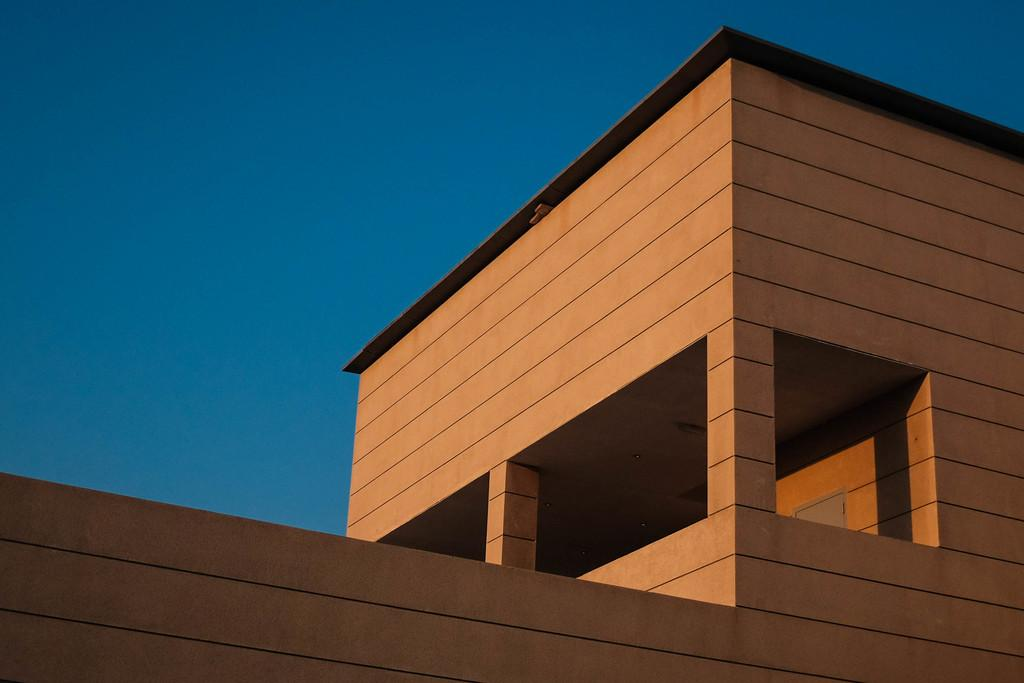What type of structure is visible in the image? There is a building in the image. How many clovers are growing on the roof of the building in the image? There is no information about clovers or the roof of the building in the image, so it cannot be determined. What type of music is the mom playing on the guitar in the image? There is no mom or guitar present in the image; only a building is visible. 